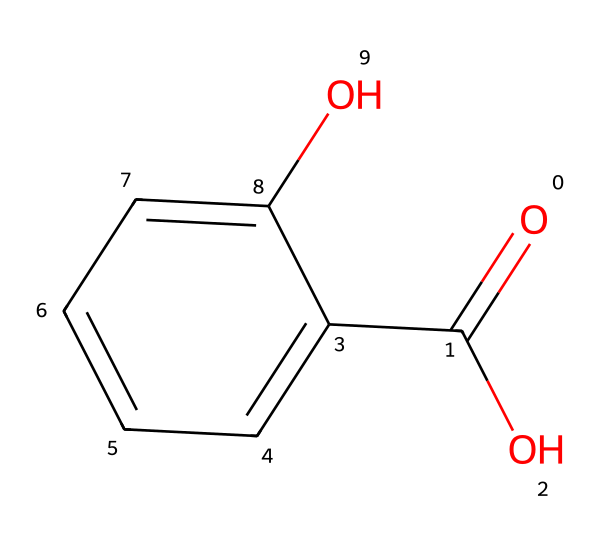How many carbon atoms are in salicylic acid? By analyzing the SMILES representation, we can count the carbon atoms. The "c" symbols represent carbon atoms in the aromatic ring, and there are 6 of them. Additionally, there is one carbon from the carboxylic acid (O=C(O)), bringing the total to 7 carbon atoms.
Answer: 7 What functional group is present in salicylic acid? The chemical structure contains the "O=C(O)" portion, which indicates the presence of a carboxylic acid group (-COOH). This is a key feature that classifies salicylic acid.
Answer: carboxylic acid What type of aromatic compound is salicylic acid? Salicylic acid contains a phenolic hydroxyl group (-OH) directly attached to a benzene ring, which classifies it specifically as a phenol.
Answer: phenol How many hydroxyl groups are present in salicylic acid? The structure shows a single -OH group attached to the benzene ring. Thus, the total number of hydroxyl groups in salicylic acid is one.
Answer: 1 What is the degree of saturation of salicylic acid? The presence of one carboxylic acid and one aromatic ring means there are no double bonds or rings that would count against saturation. Therefore, salicylic acid is fully saturated in terms of its constituent parts based on the structure.
Answer: saturated What is the molecular weight of salicylic acid? By calculating the atomic weights of all constituent atoms (carbon, hydrogen, and oxygen) in the molecular formula C7H6O3, we arrive at the total molecular weight. Summing these provides the correct answer.
Answer: 138.12 